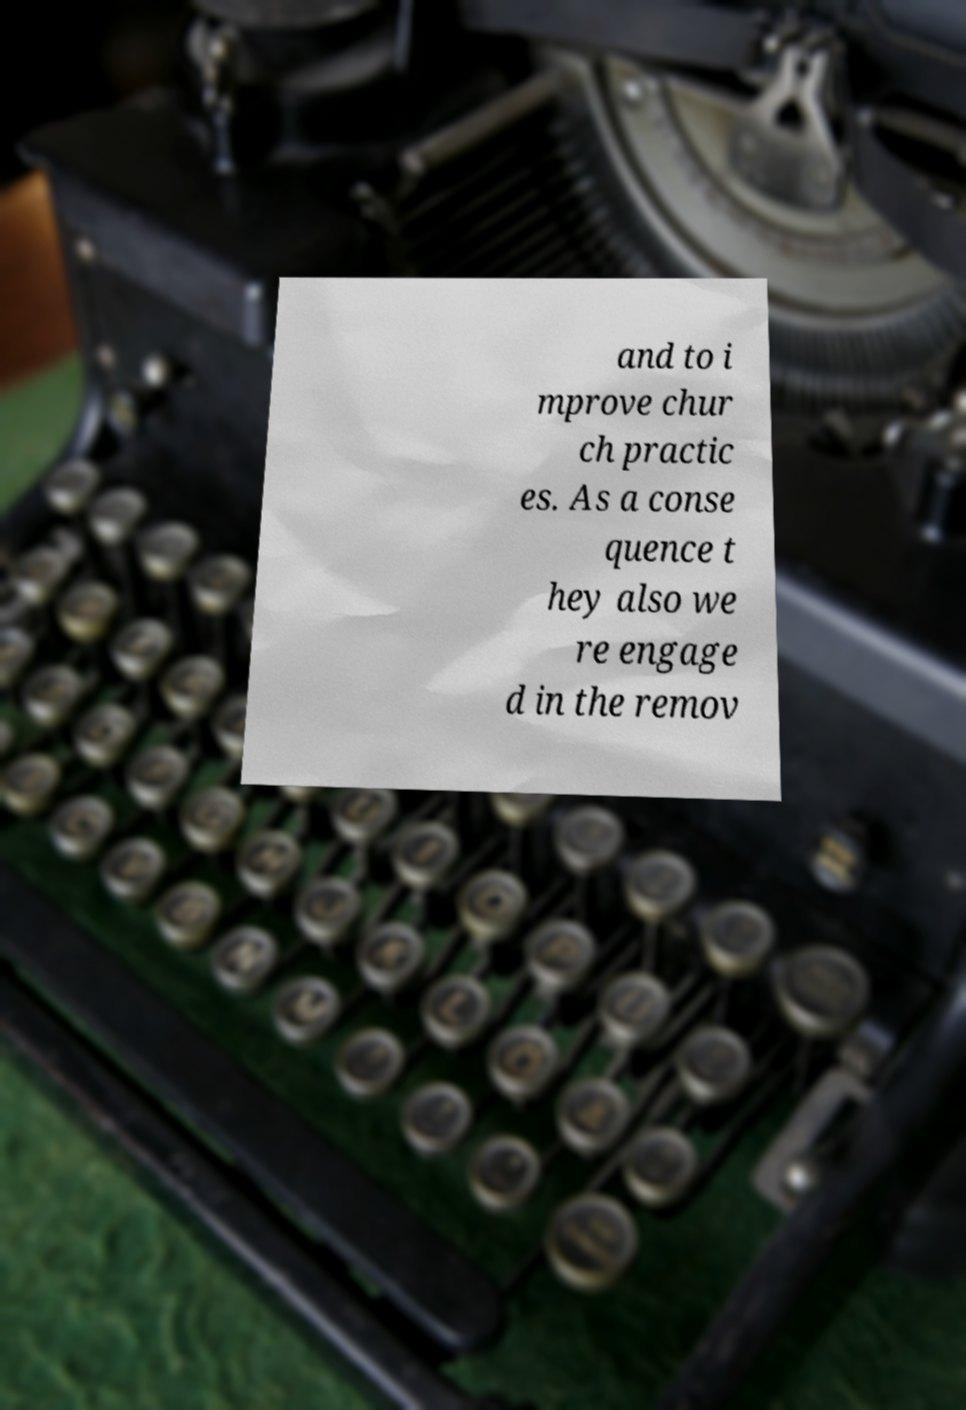There's text embedded in this image that I need extracted. Can you transcribe it verbatim? and to i mprove chur ch practic es. As a conse quence t hey also we re engage d in the remov 